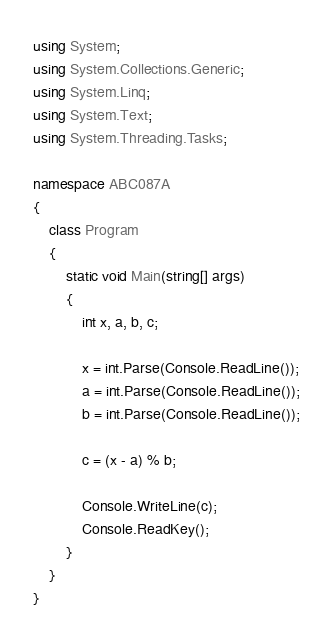<code> <loc_0><loc_0><loc_500><loc_500><_C#_>using System;
using System.Collections.Generic;
using System.Linq;
using System.Text;
using System.Threading.Tasks;

namespace ABC087A
{
    class Program
    {
        static void Main(string[] args)
        {
            int x, a, b, c;

            x = int.Parse(Console.ReadLine());
            a = int.Parse(Console.ReadLine());
            b = int.Parse(Console.ReadLine());

            c = (x - a) % b;

            Console.WriteLine(c);
            Console.ReadKey();
        }
    }
}</code> 